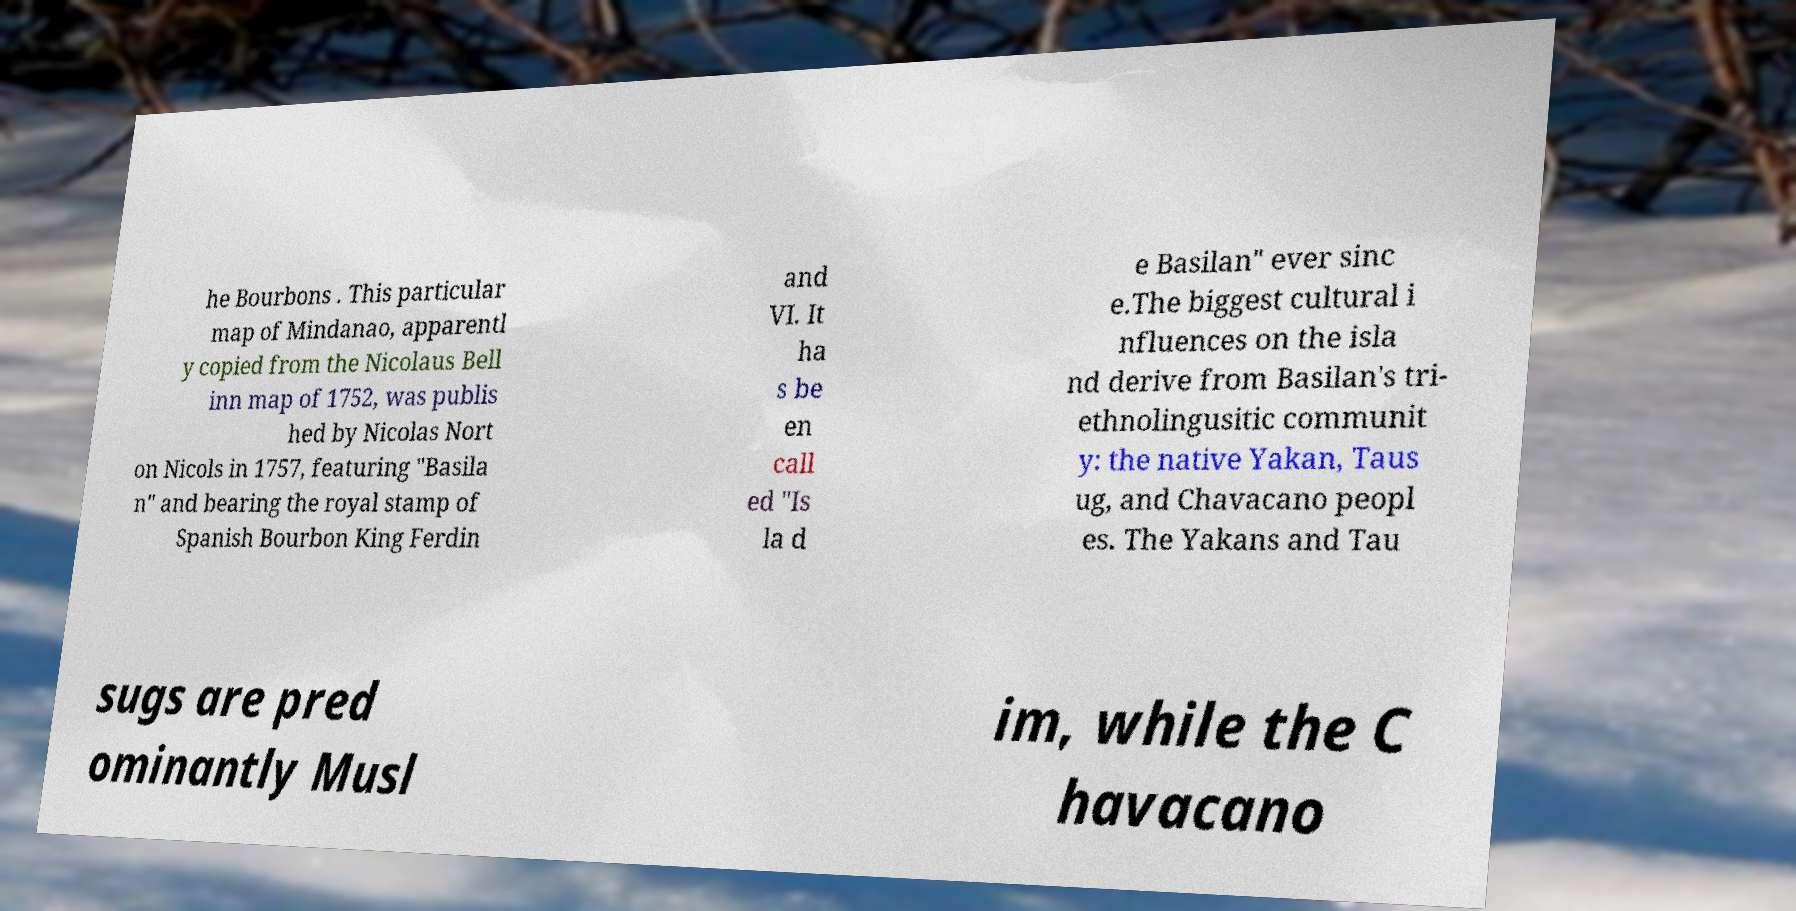Could you assist in decoding the text presented in this image and type it out clearly? he Bourbons . This particular map of Mindanao, apparentl y copied from the Nicolaus Bell inn map of 1752, was publis hed by Nicolas Nort on Nicols in 1757, featuring "Basila n" and bearing the royal stamp of Spanish Bourbon King Ferdin and VI. It ha s be en call ed "Is la d e Basilan" ever sinc e.The biggest cultural i nfluences on the isla nd derive from Basilan's tri- ethnolingusitic communit y: the native Yakan, Taus ug, and Chavacano peopl es. The Yakans and Tau sugs are pred ominantly Musl im, while the C havacano 